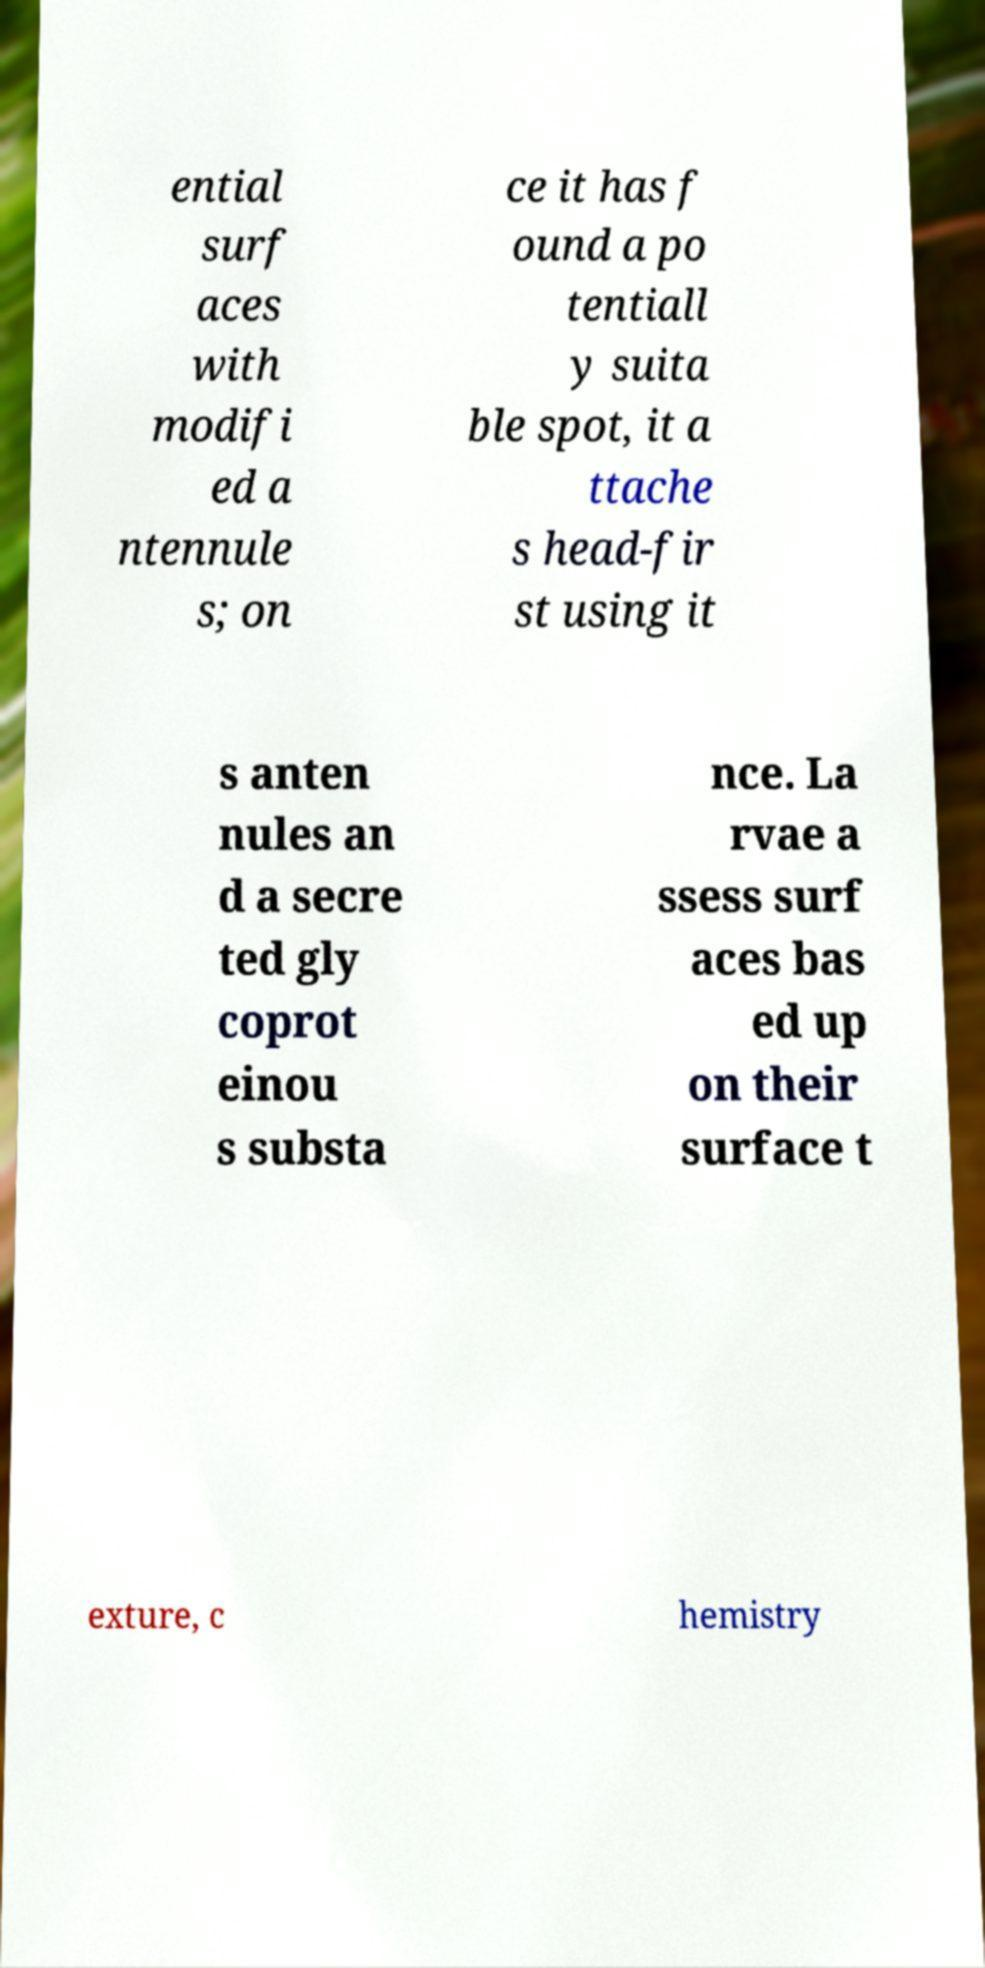There's text embedded in this image that I need extracted. Can you transcribe it verbatim? ential surf aces with modifi ed a ntennule s; on ce it has f ound a po tentiall y suita ble spot, it a ttache s head-fir st using it s anten nules an d a secre ted gly coprot einou s substa nce. La rvae a ssess surf aces bas ed up on their surface t exture, c hemistry 